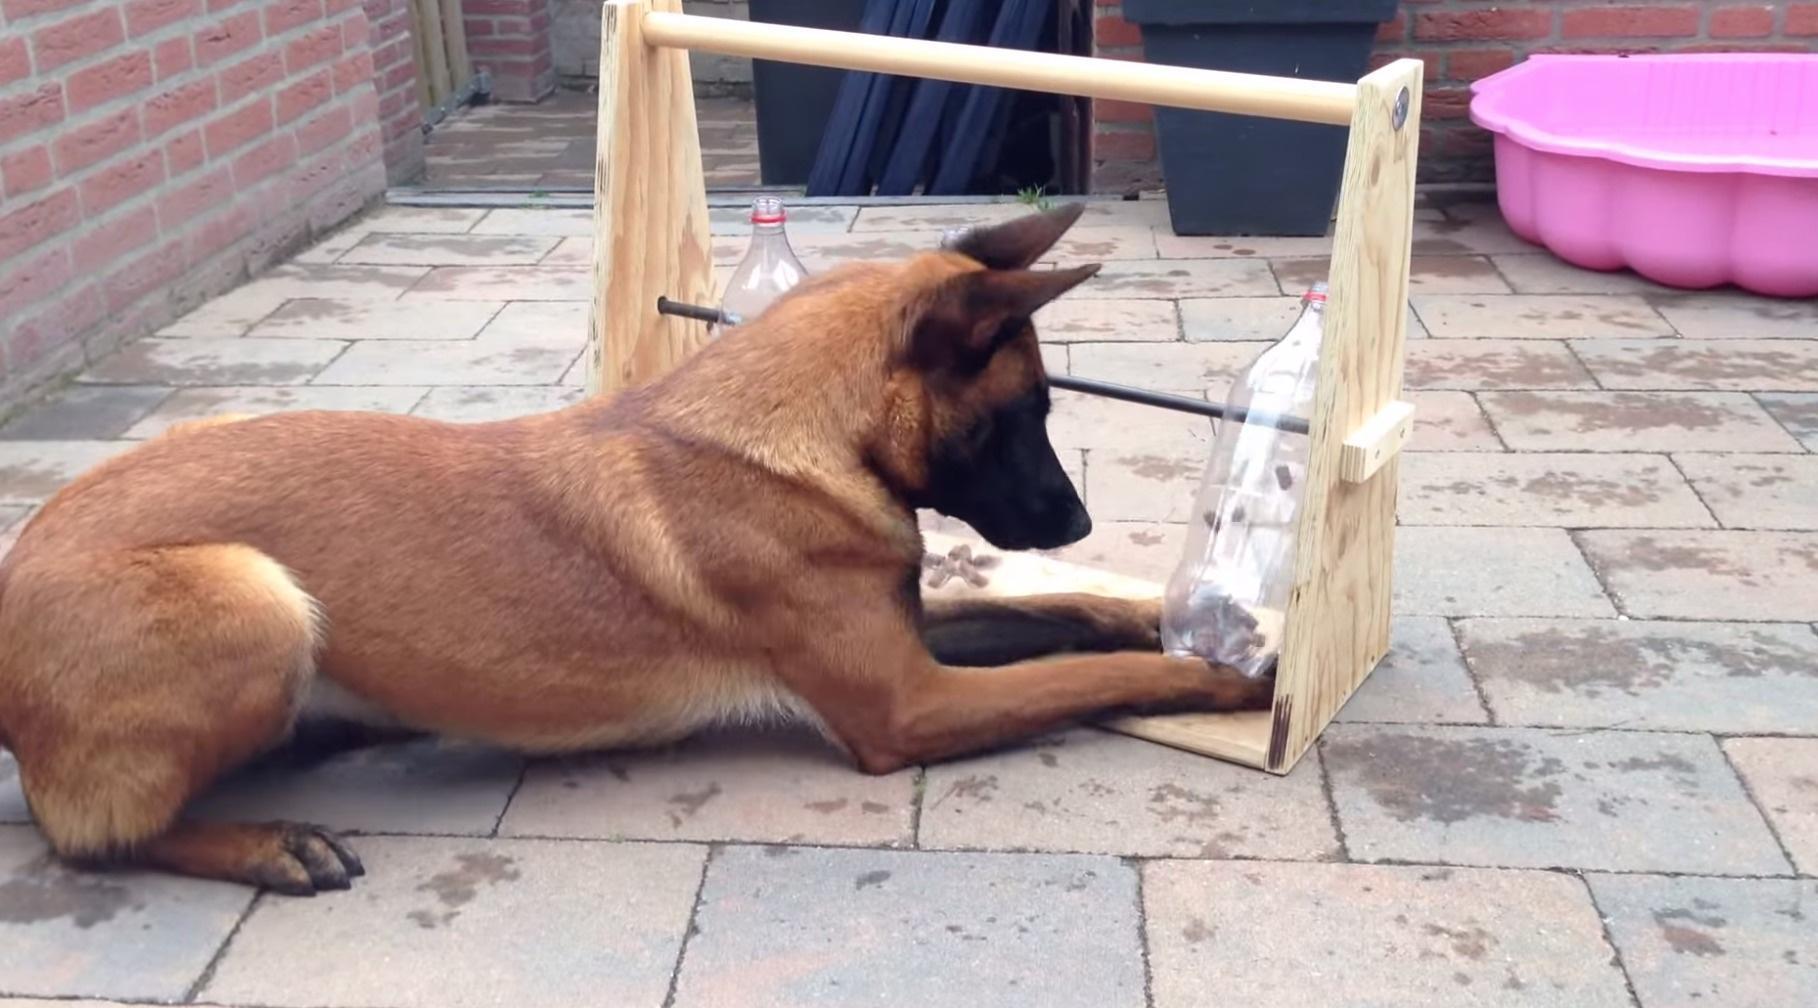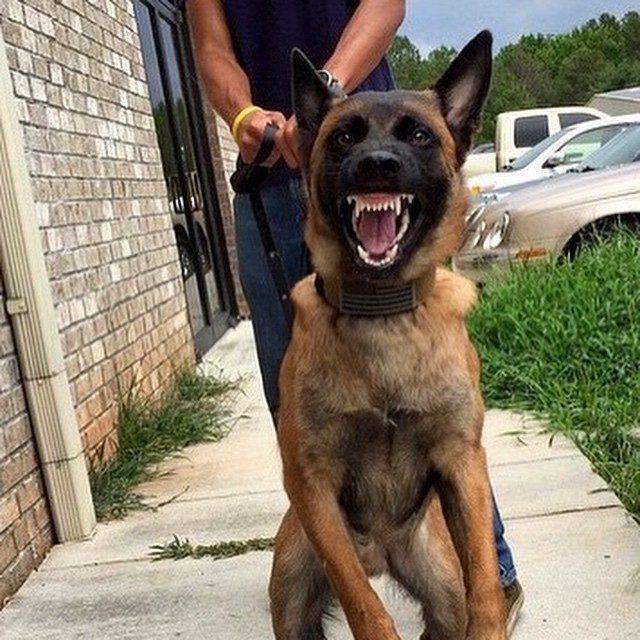The first image is the image on the left, the second image is the image on the right. Examine the images to the left and right. Is the description "The dog in the image on the right is near an area of green grass." accurate? Answer yes or no. Yes. The first image is the image on the left, the second image is the image on the right. For the images shown, is this caption "The left image contains one dog with its tongue hanging out." true? Answer yes or no. No. 